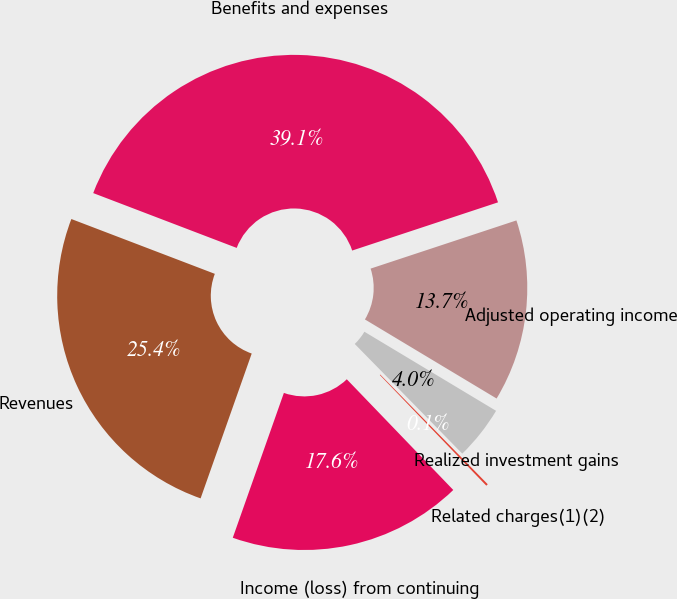Convert chart to OTSL. <chart><loc_0><loc_0><loc_500><loc_500><pie_chart><fcel>Revenues<fcel>Benefits and expenses<fcel>Adjusted operating income<fcel>Realized investment gains<fcel>Related charges(1)(2)<fcel>Income (loss) from continuing<nl><fcel>25.41%<fcel>39.11%<fcel>13.69%<fcel>4.05%<fcel>0.15%<fcel>17.59%<nl></chart> 